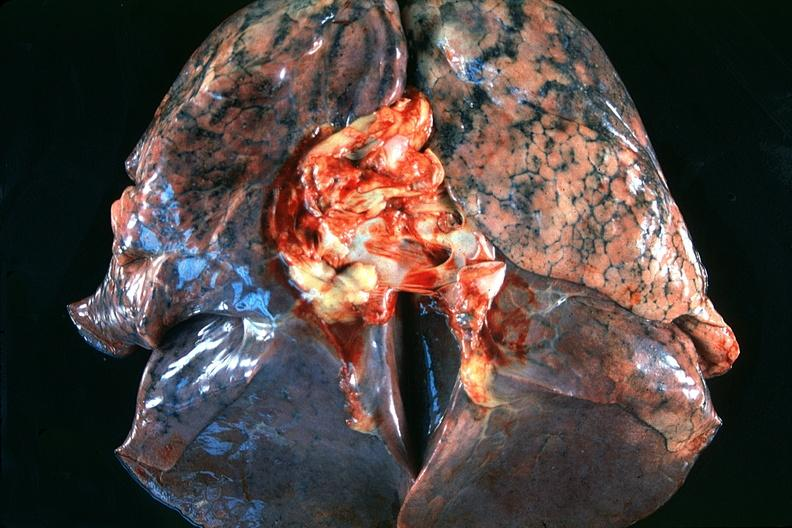what does this image show?
Answer the question using a single word or phrase. Normal lung 